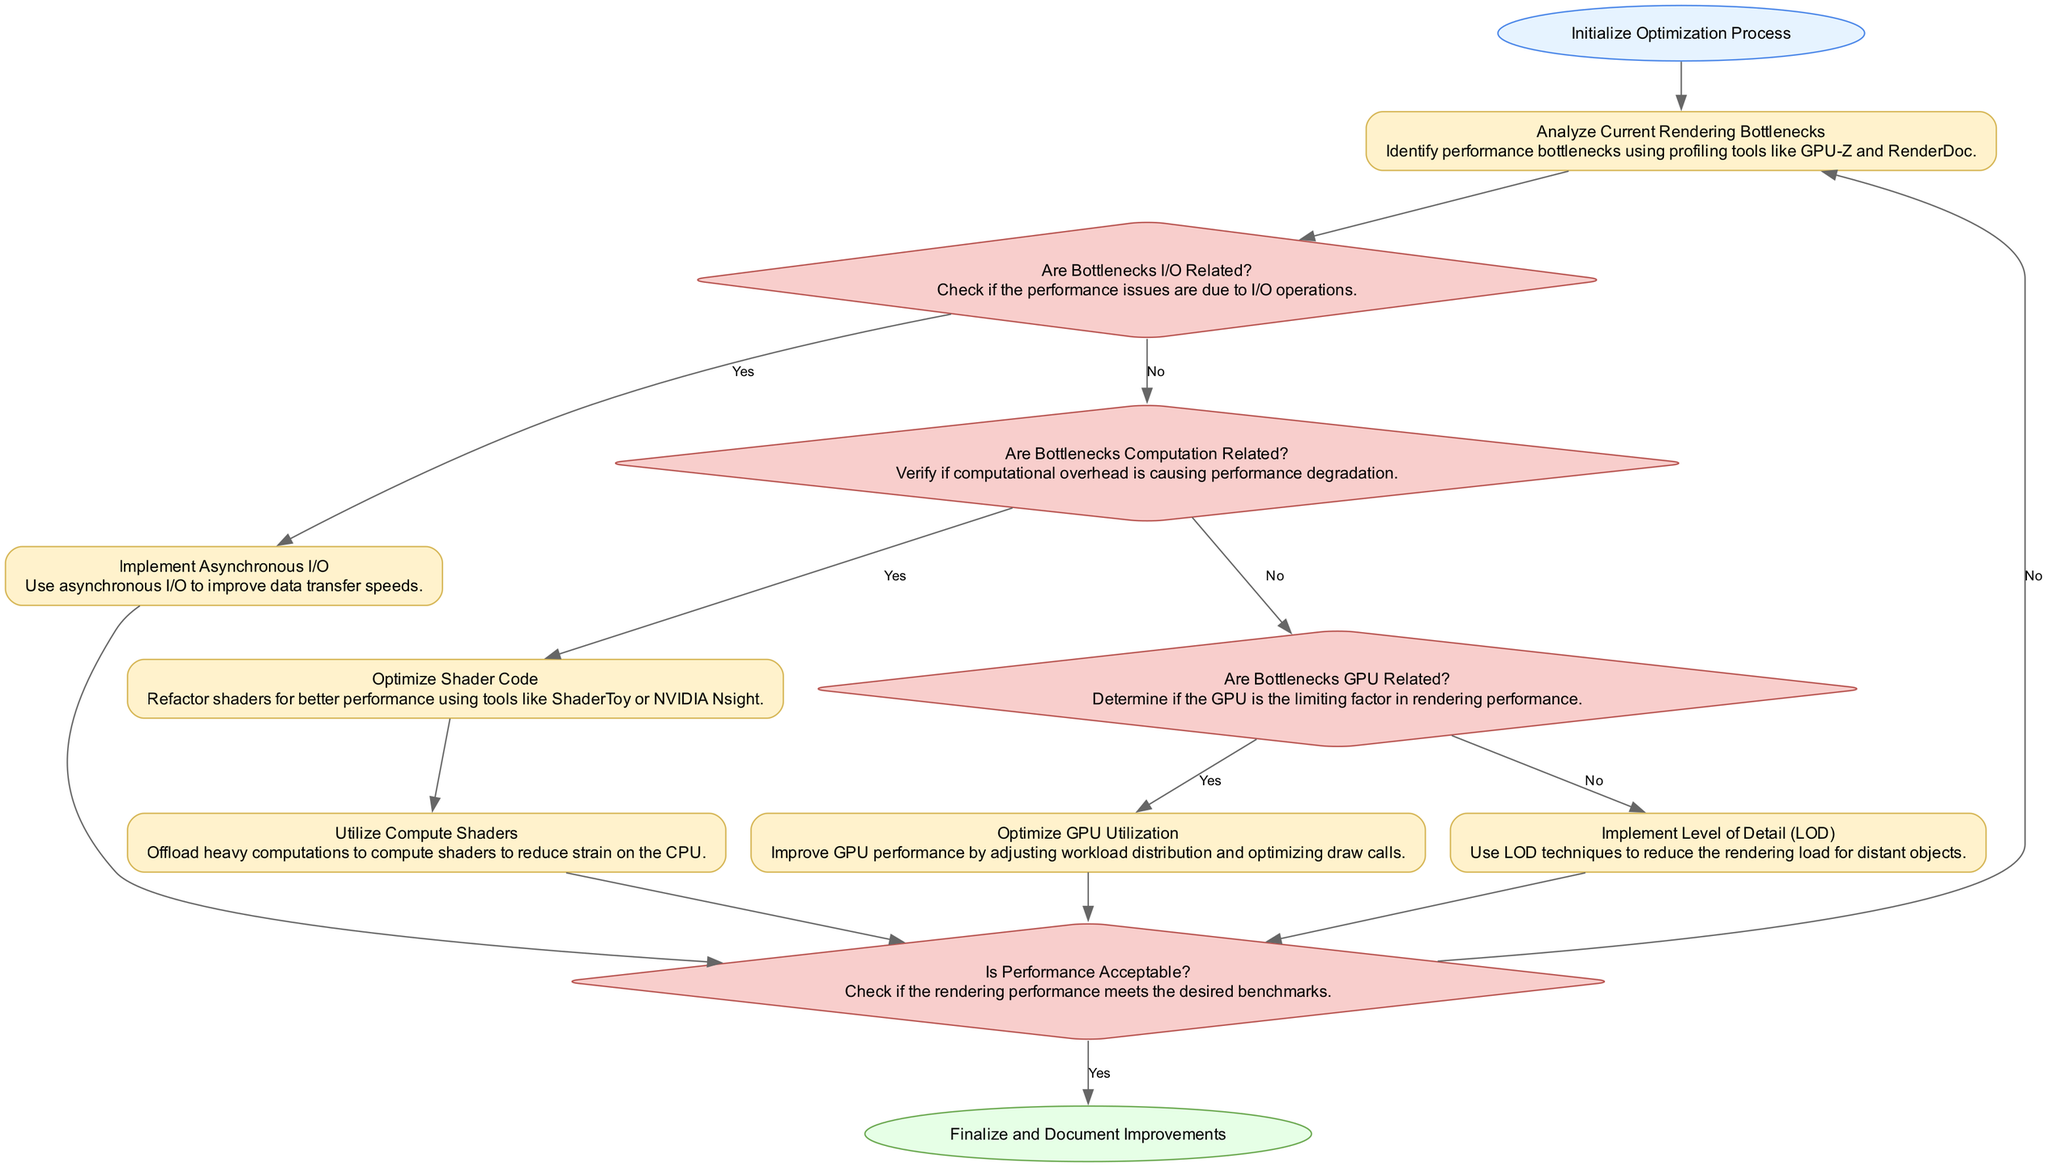What is the first step in the optimization process? The first step in the flow chart is "Initialize Optimization Process," which is represented as the starting node in the diagram.
Answer: Initialize Optimization Process How many decision nodes are present in the diagram? The diagram contains four decision nodes: "Are Bottlenecks I/O Related?", "Are Bottlenecks Computation Related?", "Are Bottlenecks GPU Related?", and "Is Performance Acceptable?".
Answer: Four What action is taken if the bottlenecks are related to computation? If the bottlenecks are found to be computation related, the next action taken is "Optimize Shader Code." This follows from the decision node "Are Bottlenecks Computation Related?".
Answer: Optimize Shader Code What happens after implementing asynchronous I/O? After "Implement Asynchronous I/O," the flow moves to the decision node "Is Performance Acceptable?" since the process checks for performance after the optimization.
Answer: Is Performance Acceptable? What operation is performed if the bottlenecks are GPU related? If it is determined that the bottlenecks are GPU related, the operation performed next is "Optimize GPU Utilization," which aims to enhance the GPU's performance.
Answer: Optimize GPU Utilization Describe the condition that leads back to re-analysis of current rendering bottlenecks. The diagram shows that if the performance is not acceptable after various optimizations, the process loops back to "Analyze Current Rendering Bottlenecks," indicating it may need further analysis and adjustment.
Answer: Analyze Current Rendering Bottlenecks What is the final step in the optimization process? The last step, denoted by the "End" node, is "Finalize and Document Improvements," which wraps up the process after confirming that performance is acceptable.
Answer: Finalize and Document Improvements How many operations are included in the optimization process? The operations included in the optimization process are: "Analyze Current Rendering Bottlenecks", "Implement Asynchronous I/O", "Optimize Shader Code", "Utilize Compute Shaders", "Optimize GPU Utilization", "Implement Level of Detail (LOD)", and "Finalize and Document Improvements", totaling six operations.
Answer: Six 